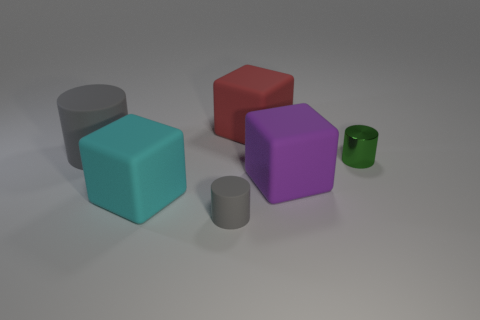Add 3 purple matte blocks. How many objects exist? 9 Add 3 large purple rubber cubes. How many large purple rubber cubes are left? 4 Add 2 large red matte blocks. How many large red matte blocks exist? 3 Subtract 0 cyan cylinders. How many objects are left? 6 Subtract all small blue metallic cubes. Subtract all small metallic cylinders. How many objects are left? 5 